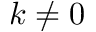Convert formula to latex. <formula><loc_0><loc_0><loc_500><loc_500>k \neq 0</formula> 